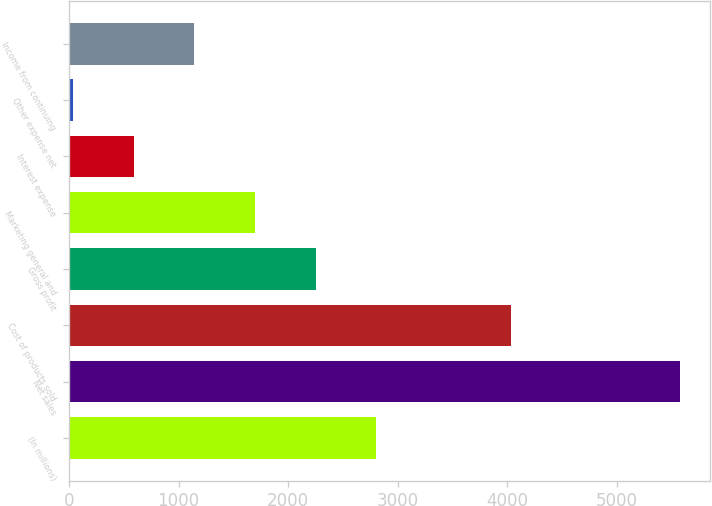<chart> <loc_0><loc_0><loc_500><loc_500><bar_chart><fcel>(In millions)<fcel>Net sales<fcel>Cost of products sold<fcel>Gross profit<fcel>Marketing general and<fcel>Interest expense<fcel>Other expense net<fcel>Income from continuing<nl><fcel>2806.05<fcel>5575.9<fcel>4037.9<fcel>2252.08<fcel>1698.11<fcel>590.17<fcel>36.2<fcel>1144.14<nl></chart> 